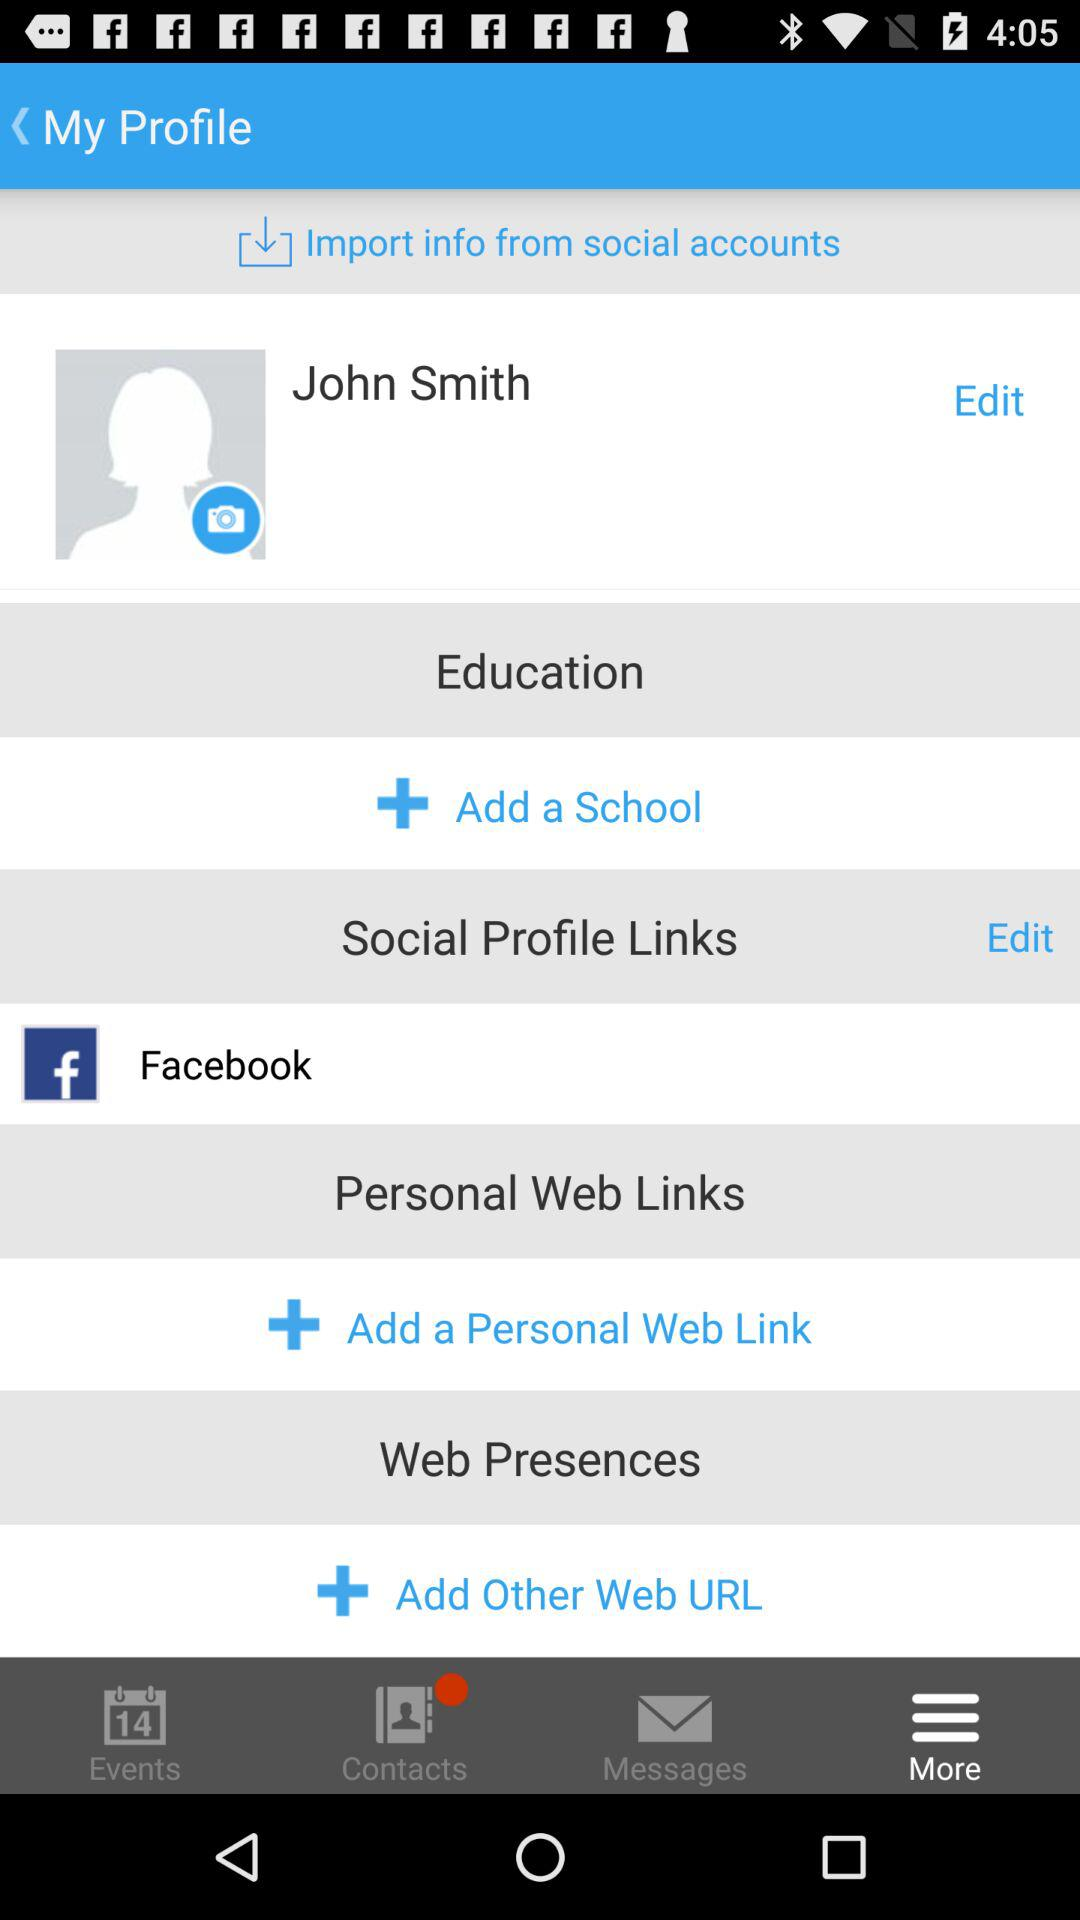Which tab is open? The tab that is open is "More". 